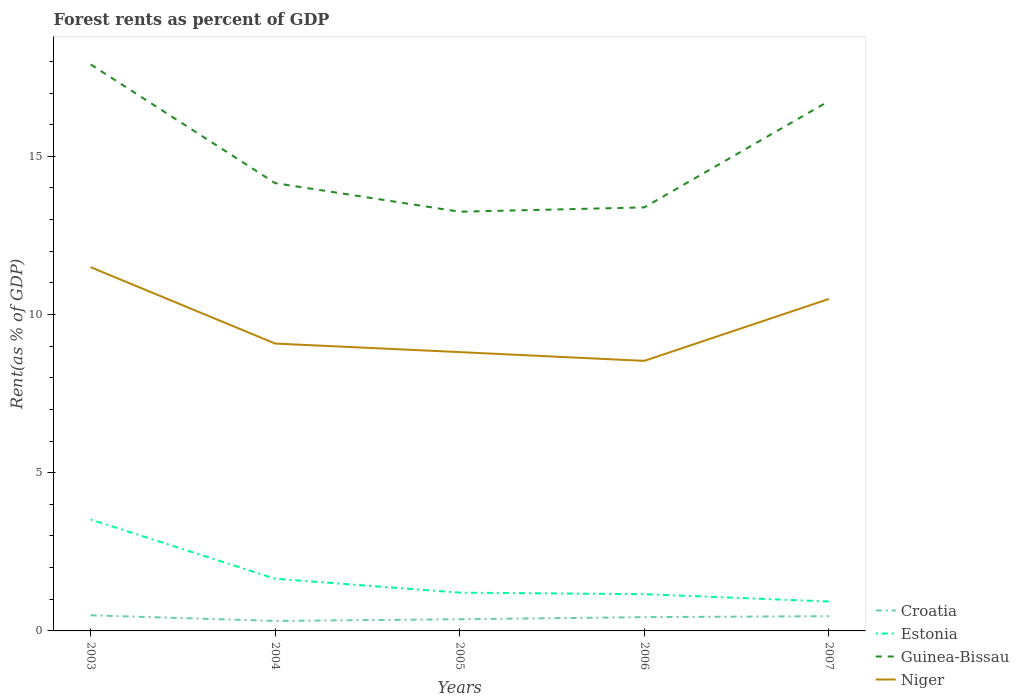How many different coloured lines are there?
Your answer should be very brief. 4. Does the line corresponding to Guinea-Bissau intersect with the line corresponding to Niger?
Provide a short and direct response. No. Across all years, what is the maximum forest rent in Niger?
Your response must be concise. 8.53. In which year was the forest rent in Guinea-Bissau maximum?
Your response must be concise. 2005. What is the total forest rent in Niger in the graph?
Give a very brief answer. 2.41. What is the difference between the highest and the second highest forest rent in Croatia?
Ensure brevity in your answer.  0.18. What is the difference between the highest and the lowest forest rent in Estonia?
Your answer should be very brief. 1. Is the forest rent in Niger strictly greater than the forest rent in Guinea-Bissau over the years?
Your response must be concise. Yes. Are the values on the major ticks of Y-axis written in scientific E-notation?
Your response must be concise. No. Does the graph contain any zero values?
Give a very brief answer. No. Where does the legend appear in the graph?
Your answer should be very brief. Bottom right. What is the title of the graph?
Provide a short and direct response. Forest rents as percent of GDP. Does "Brunei Darussalam" appear as one of the legend labels in the graph?
Offer a terse response. No. What is the label or title of the Y-axis?
Make the answer very short. Rent(as % of GDP). What is the Rent(as % of GDP) of Croatia in 2003?
Make the answer very short. 0.49. What is the Rent(as % of GDP) in Estonia in 2003?
Keep it short and to the point. 3.52. What is the Rent(as % of GDP) of Guinea-Bissau in 2003?
Make the answer very short. 17.9. What is the Rent(as % of GDP) of Niger in 2003?
Your answer should be very brief. 11.5. What is the Rent(as % of GDP) in Croatia in 2004?
Offer a terse response. 0.32. What is the Rent(as % of GDP) of Estonia in 2004?
Your answer should be compact. 1.65. What is the Rent(as % of GDP) of Guinea-Bissau in 2004?
Give a very brief answer. 14.15. What is the Rent(as % of GDP) in Niger in 2004?
Your answer should be very brief. 9.08. What is the Rent(as % of GDP) of Croatia in 2005?
Keep it short and to the point. 0.37. What is the Rent(as % of GDP) in Estonia in 2005?
Your answer should be very brief. 1.21. What is the Rent(as % of GDP) of Guinea-Bissau in 2005?
Make the answer very short. 13.25. What is the Rent(as % of GDP) in Niger in 2005?
Give a very brief answer. 8.81. What is the Rent(as % of GDP) in Croatia in 2006?
Keep it short and to the point. 0.44. What is the Rent(as % of GDP) in Estonia in 2006?
Provide a short and direct response. 1.16. What is the Rent(as % of GDP) of Guinea-Bissau in 2006?
Ensure brevity in your answer.  13.39. What is the Rent(as % of GDP) in Niger in 2006?
Provide a succinct answer. 8.53. What is the Rent(as % of GDP) in Croatia in 2007?
Your response must be concise. 0.47. What is the Rent(as % of GDP) of Estonia in 2007?
Your answer should be very brief. 0.93. What is the Rent(as % of GDP) in Guinea-Bissau in 2007?
Make the answer very short. 16.74. What is the Rent(as % of GDP) of Niger in 2007?
Ensure brevity in your answer.  10.49. Across all years, what is the maximum Rent(as % of GDP) in Croatia?
Offer a very short reply. 0.49. Across all years, what is the maximum Rent(as % of GDP) of Estonia?
Provide a short and direct response. 3.52. Across all years, what is the maximum Rent(as % of GDP) in Guinea-Bissau?
Provide a succinct answer. 17.9. Across all years, what is the maximum Rent(as % of GDP) of Niger?
Your answer should be compact. 11.5. Across all years, what is the minimum Rent(as % of GDP) of Croatia?
Provide a succinct answer. 0.32. Across all years, what is the minimum Rent(as % of GDP) of Estonia?
Your answer should be very brief. 0.93. Across all years, what is the minimum Rent(as % of GDP) in Guinea-Bissau?
Offer a terse response. 13.25. Across all years, what is the minimum Rent(as % of GDP) in Niger?
Your answer should be compact. 8.53. What is the total Rent(as % of GDP) of Croatia in the graph?
Keep it short and to the point. 2.08. What is the total Rent(as % of GDP) of Estonia in the graph?
Keep it short and to the point. 8.47. What is the total Rent(as % of GDP) in Guinea-Bissau in the graph?
Your answer should be very brief. 75.43. What is the total Rent(as % of GDP) of Niger in the graph?
Offer a terse response. 48.42. What is the difference between the Rent(as % of GDP) of Croatia in 2003 and that in 2004?
Offer a terse response. 0.18. What is the difference between the Rent(as % of GDP) in Estonia in 2003 and that in 2004?
Offer a very short reply. 1.87. What is the difference between the Rent(as % of GDP) in Guinea-Bissau in 2003 and that in 2004?
Offer a very short reply. 3.75. What is the difference between the Rent(as % of GDP) of Niger in 2003 and that in 2004?
Give a very brief answer. 2.41. What is the difference between the Rent(as % of GDP) in Croatia in 2003 and that in 2005?
Make the answer very short. 0.13. What is the difference between the Rent(as % of GDP) of Estonia in 2003 and that in 2005?
Keep it short and to the point. 2.31. What is the difference between the Rent(as % of GDP) in Guinea-Bissau in 2003 and that in 2005?
Ensure brevity in your answer.  4.66. What is the difference between the Rent(as % of GDP) of Niger in 2003 and that in 2005?
Your response must be concise. 2.68. What is the difference between the Rent(as % of GDP) of Croatia in 2003 and that in 2006?
Ensure brevity in your answer.  0.06. What is the difference between the Rent(as % of GDP) of Estonia in 2003 and that in 2006?
Your response must be concise. 2.36. What is the difference between the Rent(as % of GDP) in Guinea-Bissau in 2003 and that in 2006?
Keep it short and to the point. 4.52. What is the difference between the Rent(as % of GDP) in Niger in 2003 and that in 2006?
Provide a succinct answer. 2.96. What is the difference between the Rent(as % of GDP) of Croatia in 2003 and that in 2007?
Make the answer very short. 0.03. What is the difference between the Rent(as % of GDP) of Estonia in 2003 and that in 2007?
Make the answer very short. 2.59. What is the difference between the Rent(as % of GDP) of Guinea-Bissau in 2003 and that in 2007?
Offer a very short reply. 1.16. What is the difference between the Rent(as % of GDP) in Croatia in 2004 and that in 2005?
Offer a very short reply. -0.05. What is the difference between the Rent(as % of GDP) in Estonia in 2004 and that in 2005?
Give a very brief answer. 0.44. What is the difference between the Rent(as % of GDP) in Guinea-Bissau in 2004 and that in 2005?
Provide a succinct answer. 0.9. What is the difference between the Rent(as % of GDP) in Niger in 2004 and that in 2005?
Make the answer very short. 0.27. What is the difference between the Rent(as % of GDP) in Croatia in 2004 and that in 2006?
Your answer should be compact. -0.12. What is the difference between the Rent(as % of GDP) in Estonia in 2004 and that in 2006?
Ensure brevity in your answer.  0.49. What is the difference between the Rent(as % of GDP) in Guinea-Bissau in 2004 and that in 2006?
Provide a short and direct response. 0.77. What is the difference between the Rent(as % of GDP) in Niger in 2004 and that in 2006?
Offer a terse response. 0.55. What is the difference between the Rent(as % of GDP) in Croatia in 2004 and that in 2007?
Make the answer very short. -0.15. What is the difference between the Rent(as % of GDP) of Estonia in 2004 and that in 2007?
Make the answer very short. 0.72. What is the difference between the Rent(as % of GDP) of Guinea-Bissau in 2004 and that in 2007?
Ensure brevity in your answer.  -2.59. What is the difference between the Rent(as % of GDP) of Niger in 2004 and that in 2007?
Keep it short and to the point. -1.41. What is the difference between the Rent(as % of GDP) in Croatia in 2005 and that in 2006?
Your response must be concise. -0.07. What is the difference between the Rent(as % of GDP) in Estonia in 2005 and that in 2006?
Your response must be concise. 0.05. What is the difference between the Rent(as % of GDP) in Guinea-Bissau in 2005 and that in 2006?
Keep it short and to the point. -0.14. What is the difference between the Rent(as % of GDP) of Niger in 2005 and that in 2006?
Ensure brevity in your answer.  0.28. What is the difference between the Rent(as % of GDP) of Croatia in 2005 and that in 2007?
Provide a succinct answer. -0.1. What is the difference between the Rent(as % of GDP) in Estonia in 2005 and that in 2007?
Provide a short and direct response. 0.28. What is the difference between the Rent(as % of GDP) in Guinea-Bissau in 2005 and that in 2007?
Offer a terse response. -3.5. What is the difference between the Rent(as % of GDP) of Niger in 2005 and that in 2007?
Keep it short and to the point. -1.68. What is the difference between the Rent(as % of GDP) in Croatia in 2006 and that in 2007?
Offer a very short reply. -0.03. What is the difference between the Rent(as % of GDP) of Estonia in 2006 and that in 2007?
Offer a terse response. 0.23. What is the difference between the Rent(as % of GDP) in Guinea-Bissau in 2006 and that in 2007?
Keep it short and to the point. -3.36. What is the difference between the Rent(as % of GDP) in Niger in 2006 and that in 2007?
Keep it short and to the point. -1.96. What is the difference between the Rent(as % of GDP) of Croatia in 2003 and the Rent(as % of GDP) of Estonia in 2004?
Keep it short and to the point. -1.15. What is the difference between the Rent(as % of GDP) in Croatia in 2003 and the Rent(as % of GDP) in Guinea-Bissau in 2004?
Give a very brief answer. -13.66. What is the difference between the Rent(as % of GDP) of Croatia in 2003 and the Rent(as % of GDP) of Niger in 2004?
Keep it short and to the point. -8.59. What is the difference between the Rent(as % of GDP) of Estonia in 2003 and the Rent(as % of GDP) of Guinea-Bissau in 2004?
Ensure brevity in your answer.  -10.63. What is the difference between the Rent(as % of GDP) in Estonia in 2003 and the Rent(as % of GDP) in Niger in 2004?
Keep it short and to the point. -5.56. What is the difference between the Rent(as % of GDP) in Guinea-Bissau in 2003 and the Rent(as % of GDP) in Niger in 2004?
Offer a terse response. 8.82. What is the difference between the Rent(as % of GDP) of Croatia in 2003 and the Rent(as % of GDP) of Estonia in 2005?
Provide a succinct answer. -0.71. What is the difference between the Rent(as % of GDP) of Croatia in 2003 and the Rent(as % of GDP) of Guinea-Bissau in 2005?
Give a very brief answer. -12.75. What is the difference between the Rent(as % of GDP) of Croatia in 2003 and the Rent(as % of GDP) of Niger in 2005?
Ensure brevity in your answer.  -8.32. What is the difference between the Rent(as % of GDP) in Estonia in 2003 and the Rent(as % of GDP) in Guinea-Bissau in 2005?
Your answer should be very brief. -9.73. What is the difference between the Rent(as % of GDP) in Estonia in 2003 and the Rent(as % of GDP) in Niger in 2005?
Your response must be concise. -5.29. What is the difference between the Rent(as % of GDP) of Guinea-Bissau in 2003 and the Rent(as % of GDP) of Niger in 2005?
Your answer should be very brief. 9.09. What is the difference between the Rent(as % of GDP) of Croatia in 2003 and the Rent(as % of GDP) of Estonia in 2006?
Your answer should be very brief. -0.67. What is the difference between the Rent(as % of GDP) of Croatia in 2003 and the Rent(as % of GDP) of Guinea-Bissau in 2006?
Provide a short and direct response. -12.89. What is the difference between the Rent(as % of GDP) of Croatia in 2003 and the Rent(as % of GDP) of Niger in 2006?
Keep it short and to the point. -8.04. What is the difference between the Rent(as % of GDP) of Estonia in 2003 and the Rent(as % of GDP) of Guinea-Bissau in 2006?
Offer a very short reply. -9.86. What is the difference between the Rent(as % of GDP) in Estonia in 2003 and the Rent(as % of GDP) in Niger in 2006?
Make the answer very short. -5.01. What is the difference between the Rent(as % of GDP) in Guinea-Bissau in 2003 and the Rent(as % of GDP) in Niger in 2006?
Give a very brief answer. 9.37. What is the difference between the Rent(as % of GDP) of Croatia in 2003 and the Rent(as % of GDP) of Estonia in 2007?
Your answer should be compact. -0.43. What is the difference between the Rent(as % of GDP) of Croatia in 2003 and the Rent(as % of GDP) of Guinea-Bissau in 2007?
Give a very brief answer. -16.25. What is the difference between the Rent(as % of GDP) in Croatia in 2003 and the Rent(as % of GDP) in Niger in 2007?
Provide a short and direct response. -10. What is the difference between the Rent(as % of GDP) of Estonia in 2003 and the Rent(as % of GDP) of Guinea-Bissau in 2007?
Ensure brevity in your answer.  -13.22. What is the difference between the Rent(as % of GDP) of Estonia in 2003 and the Rent(as % of GDP) of Niger in 2007?
Your answer should be very brief. -6.97. What is the difference between the Rent(as % of GDP) in Guinea-Bissau in 2003 and the Rent(as % of GDP) in Niger in 2007?
Offer a terse response. 7.41. What is the difference between the Rent(as % of GDP) in Croatia in 2004 and the Rent(as % of GDP) in Estonia in 2005?
Ensure brevity in your answer.  -0.89. What is the difference between the Rent(as % of GDP) in Croatia in 2004 and the Rent(as % of GDP) in Guinea-Bissau in 2005?
Make the answer very short. -12.93. What is the difference between the Rent(as % of GDP) of Croatia in 2004 and the Rent(as % of GDP) of Niger in 2005?
Provide a succinct answer. -8.5. What is the difference between the Rent(as % of GDP) in Estonia in 2004 and the Rent(as % of GDP) in Guinea-Bissau in 2005?
Make the answer very short. -11.6. What is the difference between the Rent(as % of GDP) of Estonia in 2004 and the Rent(as % of GDP) of Niger in 2005?
Ensure brevity in your answer.  -7.16. What is the difference between the Rent(as % of GDP) of Guinea-Bissau in 2004 and the Rent(as % of GDP) of Niger in 2005?
Offer a very short reply. 5.34. What is the difference between the Rent(as % of GDP) of Croatia in 2004 and the Rent(as % of GDP) of Estonia in 2006?
Keep it short and to the point. -0.85. What is the difference between the Rent(as % of GDP) in Croatia in 2004 and the Rent(as % of GDP) in Guinea-Bissau in 2006?
Offer a terse response. -13.07. What is the difference between the Rent(as % of GDP) in Croatia in 2004 and the Rent(as % of GDP) in Niger in 2006?
Make the answer very short. -8.22. What is the difference between the Rent(as % of GDP) of Estonia in 2004 and the Rent(as % of GDP) of Guinea-Bissau in 2006?
Offer a very short reply. -11.74. What is the difference between the Rent(as % of GDP) in Estonia in 2004 and the Rent(as % of GDP) in Niger in 2006?
Offer a very short reply. -6.89. What is the difference between the Rent(as % of GDP) of Guinea-Bissau in 2004 and the Rent(as % of GDP) of Niger in 2006?
Your response must be concise. 5.62. What is the difference between the Rent(as % of GDP) of Croatia in 2004 and the Rent(as % of GDP) of Estonia in 2007?
Offer a very short reply. -0.61. What is the difference between the Rent(as % of GDP) in Croatia in 2004 and the Rent(as % of GDP) in Guinea-Bissau in 2007?
Offer a terse response. -16.43. What is the difference between the Rent(as % of GDP) in Croatia in 2004 and the Rent(as % of GDP) in Niger in 2007?
Your response must be concise. -10.18. What is the difference between the Rent(as % of GDP) in Estonia in 2004 and the Rent(as % of GDP) in Guinea-Bissau in 2007?
Your answer should be very brief. -15.1. What is the difference between the Rent(as % of GDP) of Estonia in 2004 and the Rent(as % of GDP) of Niger in 2007?
Your answer should be very brief. -8.84. What is the difference between the Rent(as % of GDP) of Guinea-Bissau in 2004 and the Rent(as % of GDP) of Niger in 2007?
Provide a succinct answer. 3.66. What is the difference between the Rent(as % of GDP) in Croatia in 2005 and the Rent(as % of GDP) in Estonia in 2006?
Your answer should be very brief. -0.79. What is the difference between the Rent(as % of GDP) of Croatia in 2005 and the Rent(as % of GDP) of Guinea-Bissau in 2006?
Provide a short and direct response. -13.02. What is the difference between the Rent(as % of GDP) of Croatia in 2005 and the Rent(as % of GDP) of Niger in 2006?
Offer a very short reply. -8.17. What is the difference between the Rent(as % of GDP) of Estonia in 2005 and the Rent(as % of GDP) of Guinea-Bissau in 2006?
Keep it short and to the point. -12.18. What is the difference between the Rent(as % of GDP) in Estonia in 2005 and the Rent(as % of GDP) in Niger in 2006?
Your answer should be very brief. -7.33. What is the difference between the Rent(as % of GDP) in Guinea-Bissau in 2005 and the Rent(as % of GDP) in Niger in 2006?
Your answer should be compact. 4.71. What is the difference between the Rent(as % of GDP) of Croatia in 2005 and the Rent(as % of GDP) of Estonia in 2007?
Keep it short and to the point. -0.56. What is the difference between the Rent(as % of GDP) in Croatia in 2005 and the Rent(as % of GDP) in Guinea-Bissau in 2007?
Your answer should be compact. -16.38. What is the difference between the Rent(as % of GDP) of Croatia in 2005 and the Rent(as % of GDP) of Niger in 2007?
Your response must be concise. -10.12. What is the difference between the Rent(as % of GDP) of Estonia in 2005 and the Rent(as % of GDP) of Guinea-Bissau in 2007?
Your answer should be very brief. -15.53. What is the difference between the Rent(as % of GDP) in Estonia in 2005 and the Rent(as % of GDP) in Niger in 2007?
Your response must be concise. -9.28. What is the difference between the Rent(as % of GDP) of Guinea-Bissau in 2005 and the Rent(as % of GDP) of Niger in 2007?
Provide a short and direct response. 2.76. What is the difference between the Rent(as % of GDP) of Croatia in 2006 and the Rent(as % of GDP) of Estonia in 2007?
Offer a terse response. -0.49. What is the difference between the Rent(as % of GDP) of Croatia in 2006 and the Rent(as % of GDP) of Guinea-Bissau in 2007?
Give a very brief answer. -16.31. What is the difference between the Rent(as % of GDP) in Croatia in 2006 and the Rent(as % of GDP) in Niger in 2007?
Your answer should be compact. -10.06. What is the difference between the Rent(as % of GDP) of Estonia in 2006 and the Rent(as % of GDP) of Guinea-Bissau in 2007?
Make the answer very short. -15.58. What is the difference between the Rent(as % of GDP) of Estonia in 2006 and the Rent(as % of GDP) of Niger in 2007?
Your answer should be compact. -9.33. What is the difference between the Rent(as % of GDP) of Guinea-Bissau in 2006 and the Rent(as % of GDP) of Niger in 2007?
Provide a succinct answer. 2.89. What is the average Rent(as % of GDP) in Croatia per year?
Keep it short and to the point. 0.42. What is the average Rent(as % of GDP) in Estonia per year?
Your answer should be compact. 1.69. What is the average Rent(as % of GDP) of Guinea-Bissau per year?
Your response must be concise. 15.09. What is the average Rent(as % of GDP) of Niger per year?
Your response must be concise. 9.68. In the year 2003, what is the difference between the Rent(as % of GDP) in Croatia and Rent(as % of GDP) in Estonia?
Offer a terse response. -3.03. In the year 2003, what is the difference between the Rent(as % of GDP) in Croatia and Rent(as % of GDP) in Guinea-Bissau?
Make the answer very short. -17.41. In the year 2003, what is the difference between the Rent(as % of GDP) in Croatia and Rent(as % of GDP) in Niger?
Provide a short and direct response. -11. In the year 2003, what is the difference between the Rent(as % of GDP) in Estonia and Rent(as % of GDP) in Guinea-Bissau?
Keep it short and to the point. -14.38. In the year 2003, what is the difference between the Rent(as % of GDP) in Estonia and Rent(as % of GDP) in Niger?
Your response must be concise. -7.98. In the year 2003, what is the difference between the Rent(as % of GDP) in Guinea-Bissau and Rent(as % of GDP) in Niger?
Ensure brevity in your answer.  6.41. In the year 2004, what is the difference between the Rent(as % of GDP) in Croatia and Rent(as % of GDP) in Estonia?
Offer a very short reply. -1.33. In the year 2004, what is the difference between the Rent(as % of GDP) of Croatia and Rent(as % of GDP) of Guinea-Bissau?
Offer a very short reply. -13.84. In the year 2004, what is the difference between the Rent(as % of GDP) in Croatia and Rent(as % of GDP) in Niger?
Ensure brevity in your answer.  -8.77. In the year 2004, what is the difference between the Rent(as % of GDP) of Estonia and Rent(as % of GDP) of Guinea-Bissau?
Your answer should be very brief. -12.5. In the year 2004, what is the difference between the Rent(as % of GDP) of Estonia and Rent(as % of GDP) of Niger?
Ensure brevity in your answer.  -7.43. In the year 2004, what is the difference between the Rent(as % of GDP) in Guinea-Bissau and Rent(as % of GDP) in Niger?
Your answer should be compact. 5.07. In the year 2005, what is the difference between the Rent(as % of GDP) of Croatia and Rent(as % of GDP) of Estonia?
Give a very brief answer. -0.84. In the year 2005, what is the difference between the Rent(as % of GDP) of Croatia and Rent(as % of GDP) of Guinea-Bissau?
Provide a succinct answer. -12.88. In the year 2005, what is the difference between the Rent(as % of GDP) of Croatia and Rent(as % of GDP) of Niger?
Provide a succinct answer. -8.44. In the year 2005, what is the difference between the Rent(as % of GDP) of Estonia and Rent(as % of GDP) of Guinea-Bissau?
Your response must be concise. -12.04. In the year 2005, what is the difference between the Rent(as % of GDP) in Estonia and Rent(as % of GDP) in Niger?
Make the answer very short. -7.6. In the year 2005, what is the difference between the Rent(as % of GDP) in Guinea-Bissau and Rent(as % of GDP) in Niger?
Provide a short and direct response. 4.44. In the year 2006, what is the difference between the Rent(as % of GDP) of Croatia and Rent(as % of GDP) of Estonia?
Your answer should be very brief. -0.73. In the year 2006, what is the difference between the Rent(as % of GDP) in Croatia and Rent(as % of GDP) in Guinea-Bissau?
Keep it short and to the point. -12.95. In the year 2006, what is the difference between the Rent(as % of GDP) in Croatia and Rent(as % of GDP) in Niger?
Offer a terse response. -8.1. In the year 2006, what is the difference between the Rent(as % of GDP) in Estonia and Rent(as % of GDP) in Guinea-Bissau?
Your response must be concise. -12.22. In the year 2006, what is the difference between the Rent(as % of GDP) in Estonia and Rent(as % of GDP) in Niger?
Keep it short and to the point. -7.37. In the year 2006, what is the difference between the Rent(as % of GDP) in Guinea-Bissau and Rent(as % of GDP) in Niger?
Ensure brevity in your answer.  4.85. In the year 2007, what is the difference between the Rent(as % of GDP) of Croatia and Rent(as % of GDP) of Estonia?
Your response must be concise. -0.46. In the year 2007, what is the difference between the Rent(as % of GDP) in Croatia and Rent(as % of GDP) in Guinea-Bissau?
Make the answer very short. -16.28. In the year 2007, what is the difference between the Rent(as % of GDP) of Croatia and Rent(as % of GDP) of Niger?
Your answer should be very brief. -10.02. In the year 2007, what is the difference between the Rent(as % of GDP) of Estonia and Rent(as % of GDP) of Guinea-Bissau?
Make the answer very short. -15.81. In the year 2007, what is the difference between the Rent(as % of GDP) of Estonia and Rent(as % of GDP) of Niger?
Make the answer very short. -9.56. In the year 2007, what is the difference between the Rent(as % of GDP) of Guinea-Bissau and Rent(as % of GDP) of Niger?
Your answer should be compact. 6.25. What is the ratio of the Rent(as % of GDP) of Croatia in 2003 to that in 2004?
Provide a short and direct response. 1.57. What is the ratio of the Rent(as % of GDP) in Estonia in 2003 to that in 2004?
Ensure brevity in your answer.  2.14. What is the ratio of the Rent(as % of GDP) of Guinea-Bissau in 2003 to that in 2004?
Give a very brief answer. 1.27. What is the ratio of the Rent(as % of GDP) in Niger in 2003 to that in 2004?
Provide a succinct answer. 1.27. What is the ratio of the Rent(as % of GDP) of Croatia in 2003 to that in 2005?
Keep it short and to the point. 1.34. What is the ratio of the Rent(as % of GDP) in Estonia in 2003 to that in 2005?
Your response must be concise. 2.91. What is the ratio of the Rent(as % of GDP) of Guinea-Bissau in 2003 to that in 2005?
Ensure brevity in your answer.  1.35. What is the ratio of the Rent(as % of GDP) of Niger in 2003 to that in 2005?
Give a very brief answer. 1.3. What is the ratio of the Rent(as % of GDP) of Croatia in 2003 to that in 2006?
Give a very brief answer. 1.14. What is the ratio of the Rent(as % of GDP) of Estonia in 2003 to that in 2006?
Provide a short and direct response. 3.03. What is the ratio of the Rent(as % of GDP) in Guinea-Bissau in 2003 to that in 2006?
Offer a very short reply. 1.34. What is the ratio of the Rent(as % of GDP) of Niger in 2003 to that in 2006?
Your answer should be compact. 1.35. What is the ratio of the Rent(as % of GDP) of Croatia in 2003 to that in 2007?
Keep it short and to the point. 1.06. What is the ratio of the Rent(as % of GDP) in Estonia in 2003 to that in 2007?
Make the answer very short. 3.79. What is the ratio of the Rent(as % of GDP) in Guinea-Bissau in 2003 to that in 2007?
Your answer should be very brief. 1.07. What is the ratio of the Rent(as % of GDP) of Niger in 2003 to that in 2007?
Your answer should be compact. 1.1. What is the ratio of the Rent(as % of GDP) of Croatia in 2004 to that in 2005?
Keep it short and to the point. 0.85. What is the ratio of the Rent(as % of GDP) of Estonia in 2004 to that in 2005?
Offer a very short reply. 1.36. What is the ratio of the Rent(as % of GDP) of Guinea-Bissau in 2004 to that in 2005?
Make the answer very short. 1.07. What is the ratio of the Rent(as % of GDP) of Niger in 2004 to that in 2005?
Your answer should be compact. 1.03. What is the ratio of the Rent(as % of GDP) of Croatia in 2004 to that in 2006?
Give a very brief answer. 0.72. What is the ratio of the Rent(as % of GDP) in Estonia in 2004 to that in 2006?
Give a very brief answer. 1.42. What is the ratio of the Rent(as % of GDP) of Guinea-Bissau in 2004 to that in 2006?
Ensure brevity in your answer.  1.06. What is the ratio of the Rent(as % of GDP) of Niger in 2004 to that in 2006?
Your response must be concise. 1.06. What is the ratio of the Rent(as % of GDP) in Croatia in 2004 to that in 2007?
Make the answer very short. 0.68. What is the ratio of the Rent(as % of GDP) in Estonia in 2004 to that in 2007?
Make the answer very short. 1.77. What is the ratio of the Rent(as % of GDP) in Guinea-Bissau in 2004 to that in 2007?
Provide a succinct answer. 0.85. What is the ratio of the Rent(as % of GDP) in Niger in 2004 to that in 2007?
Keep it short and to the point. 0.87. What is the ratio of the Rent(as % of GDP) in Croatia in 2005 to that in 2006?
Offer a terse response. 0.85. What is the ratio of the Rent(as % of GDP) of Estonia in 2005 to that in 2006?
Your response must be concise. 1.04. What is the ratio of the Rent(as % of GDP) in Niger in 2005 to that in 2006?
Give a very brief answer. 1.03. What is the ratio of the Rent(as % of GDP) of Croatia in 2005 to that in 2007?
Offer a terse response. 0.79. What is the ratio of the Rent(as % of GDP) in Estonia in 2005 to that in 2007?
Offer a very short reply. 1.3. What is the ratio of the Rent(as % of GDP) of Guinea-Bissau in 2005 to that in 2007?
Ensure brevity in your answer.  0.79. What is the ratio of the Rent(as % of GDP) of Niger in 2005 to that in 2007?
Your answer should be compact. 0.84. What is the ratio of the Rent(as % of GDP) of Croatia in 2006 to that in 2007?
Keep it short and to the point. 0.93. What is the ratio of the Rent(as % of GDP) of Estonia in 2006 to that in 2007?
Provide a short and direct response. 1.25. What is the ratio of the Rent(as % of GDP) of Guinea-Bissau in 2006 to that in 2007?
Provide a succinct answer. 0.8. What is the ratio of the Rent(as % of GDP) in Niger in 2006 to that in 2007?
Your answer should be compact. 0.81. What is the difference between the highest and the second highest Rent(as % of GDP) of Croatia?
Give a very brief answer. 0.03. What is the difference between the highest and the second highest Rent(as % of GDP) of Estonia?
Offer a terse response. 1.87. What is the difference between the highest and the second highest Rent(as % of GDP) of Guinea-Bissau?
Offer a very short reply. 1.16. What is the difference between the highest and the second highest Rent(as % of GDP) of Niger?
Offer a very short reply. 1. What is the difference between the highest and the lowest Rent(as % of GDP) of Croatia?
Give a very brief answer. 0.18. What is the difference between the highest and the lowest Rent(as % of GDP) of Estonia?
Provide a short and direct response. 2.59. What is the difference between the highest and the lowest Rent(as % of GDP) in Guinea-Bissau?
Give a very brief answer. 4.66. What is the difference between the highest and the lowest Rent(as % of GDP) of Niger?
Keep it short and to the point. 2.96. 